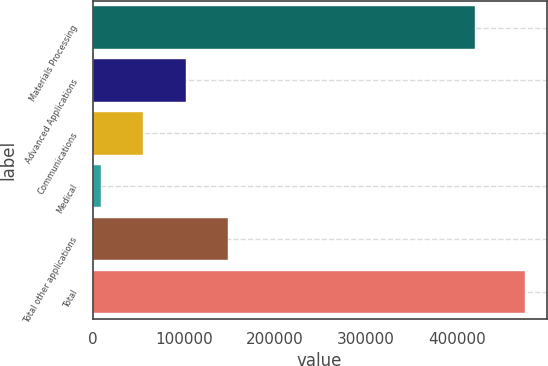<chart> <loc_0><loc_0><loc_500><loc_500><bar_chart><fcel>Materials Processing<fcel>Advanced Applications<fcel>Communications<fcel>Medical<fcel>Total other applications<fcel>Total<nl><fcel>419443<fcel>101899<fcel>55325.9<fcel>8753<fcel>148472<fcel>474482<nl></chart> 